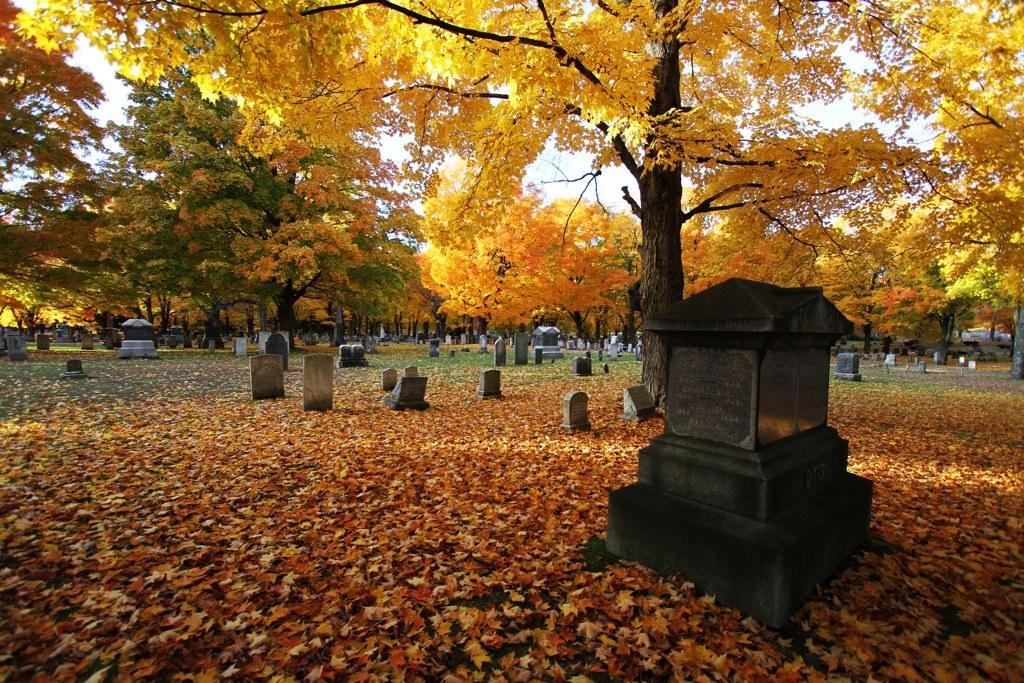What is present at the bottom of the image? There are leaves at the bottom of the image. What can be seen in the image besides the leaves? There are graves in the image. What type of vegetation is visible in the background of the image? There are trees in the background of the image. What is visible at the top of the image? The sky is visible at the top of the image. What type of band is playing in the background of the image? There is no band present in the image; it features leaves, graves, trees, and the sky. What color is the bead that is hanging from the tree in the image? There is no bead hanging from the tree in the image. 